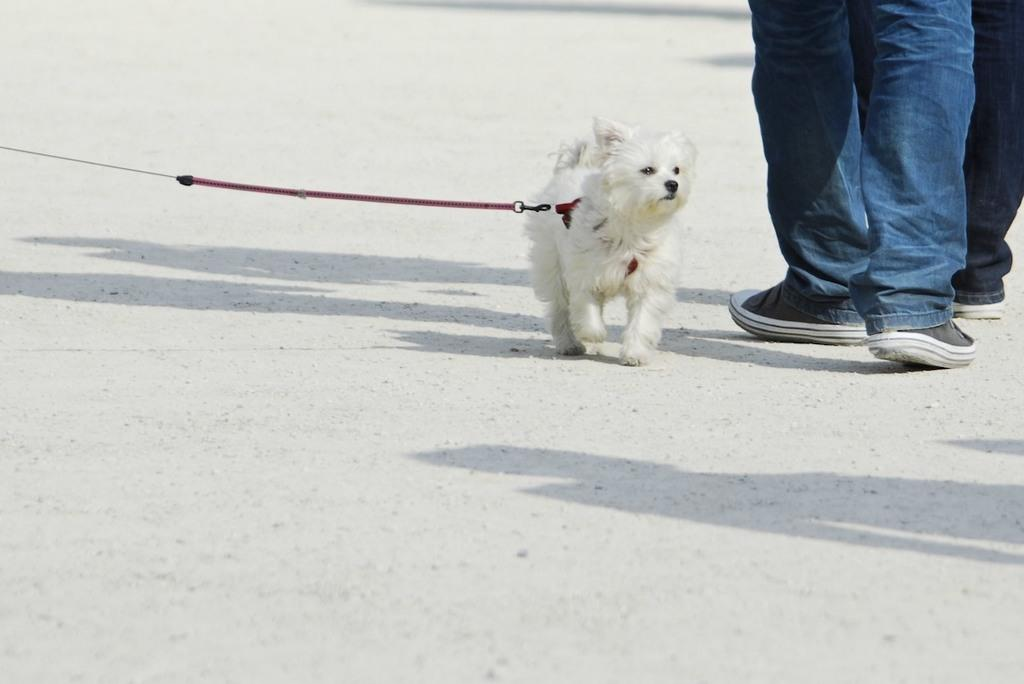What type of animal is in the image? There is a puppy in the image. What is the puppy doing in the image? The puppy is walking. Can you describe any other elements in the image? There are legs of two persons in the image. What type of sponge can be seen being used by the puppy in the image? There is no sponge present in the image, and the puppy is not using any tools or objects. 